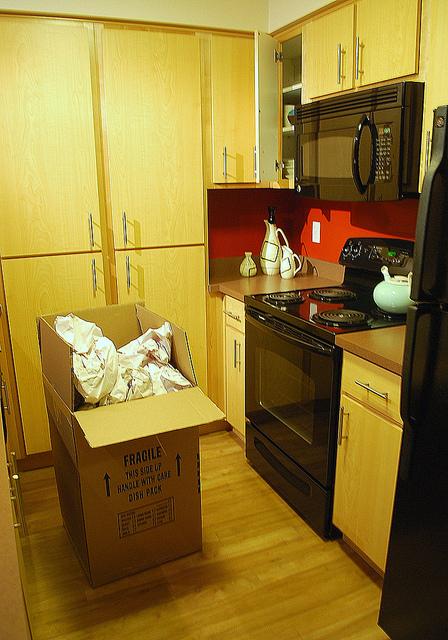Are they packing or unpacking the box?
Be succinct. Unpacking. How many cabinets and cupboards are there?
Keep it brief. 10. Where is the kettle?
Keep it brief. Stove. 